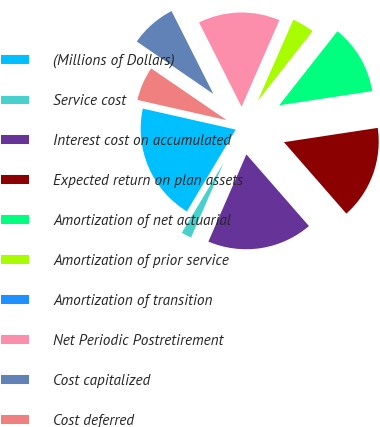Convert chart. <chart><loc_0><loc_0><loc_500><loc_500><pie_chart><fcel>(Millions of Dollars)<fcel>Service cost<fcel>Interest cost on accumulated<fcel>Expected return on plan assets<fcel>Amortization of net actuarial<fcel>Amortization of prior service<fcel>Amortization of transition<fcel>Net Periodic Postretirement<fcel>Cost capitalized<fcel>Cost deferred<nl><fcel>19.96%<fcel>2.03%<fcel>17.97%<fcel>15.98%<fcel>11.99%<fcel>4.02%<fcel>0.04%<fcel>13.98%<fcel>8.01%<fcel>6.02%<nl></chart> 